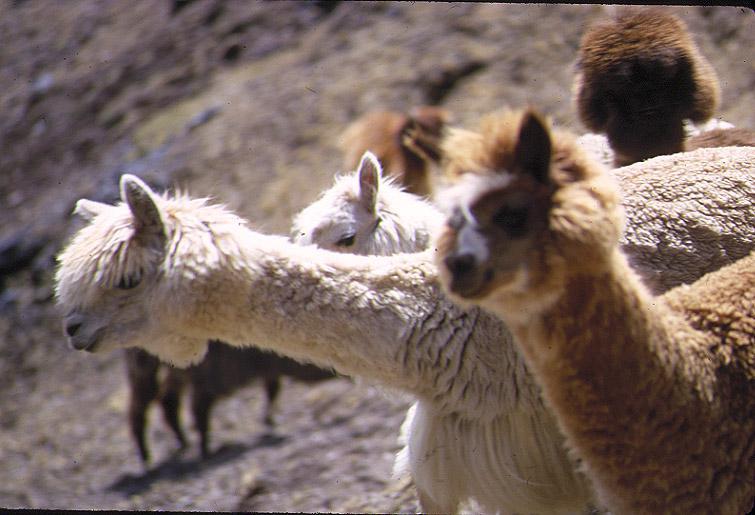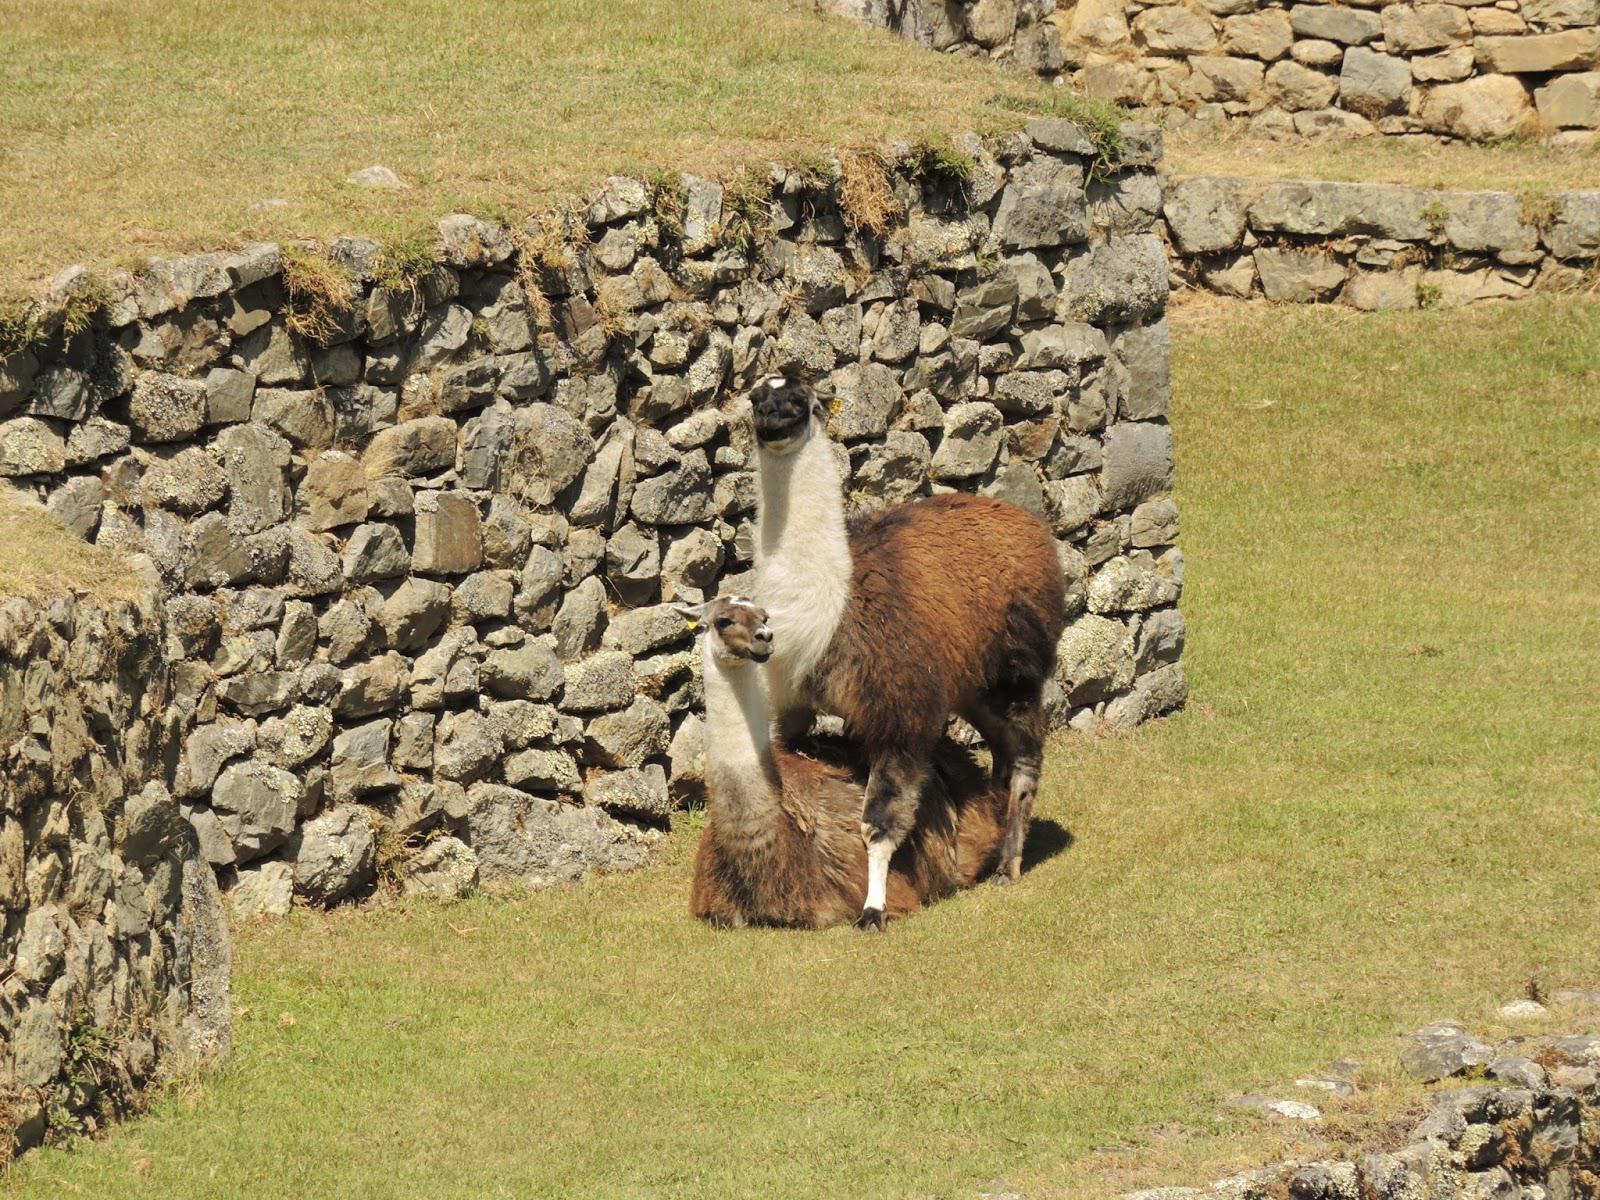The first image is the image on the left, the second image is the image on the right. Evaluate the accuracy of this statement regarding the images: "In one image, two llamas - including a brown-and-white one - are next to a rustic stone wall.". Is it true? Answer yes or no. Yes. The first image is the image on the left, the second image is the image on the right. Examine the images to the left and right. Is the description "One llama is not standing on four legs." accurate? Answer yes or no. Yes. 